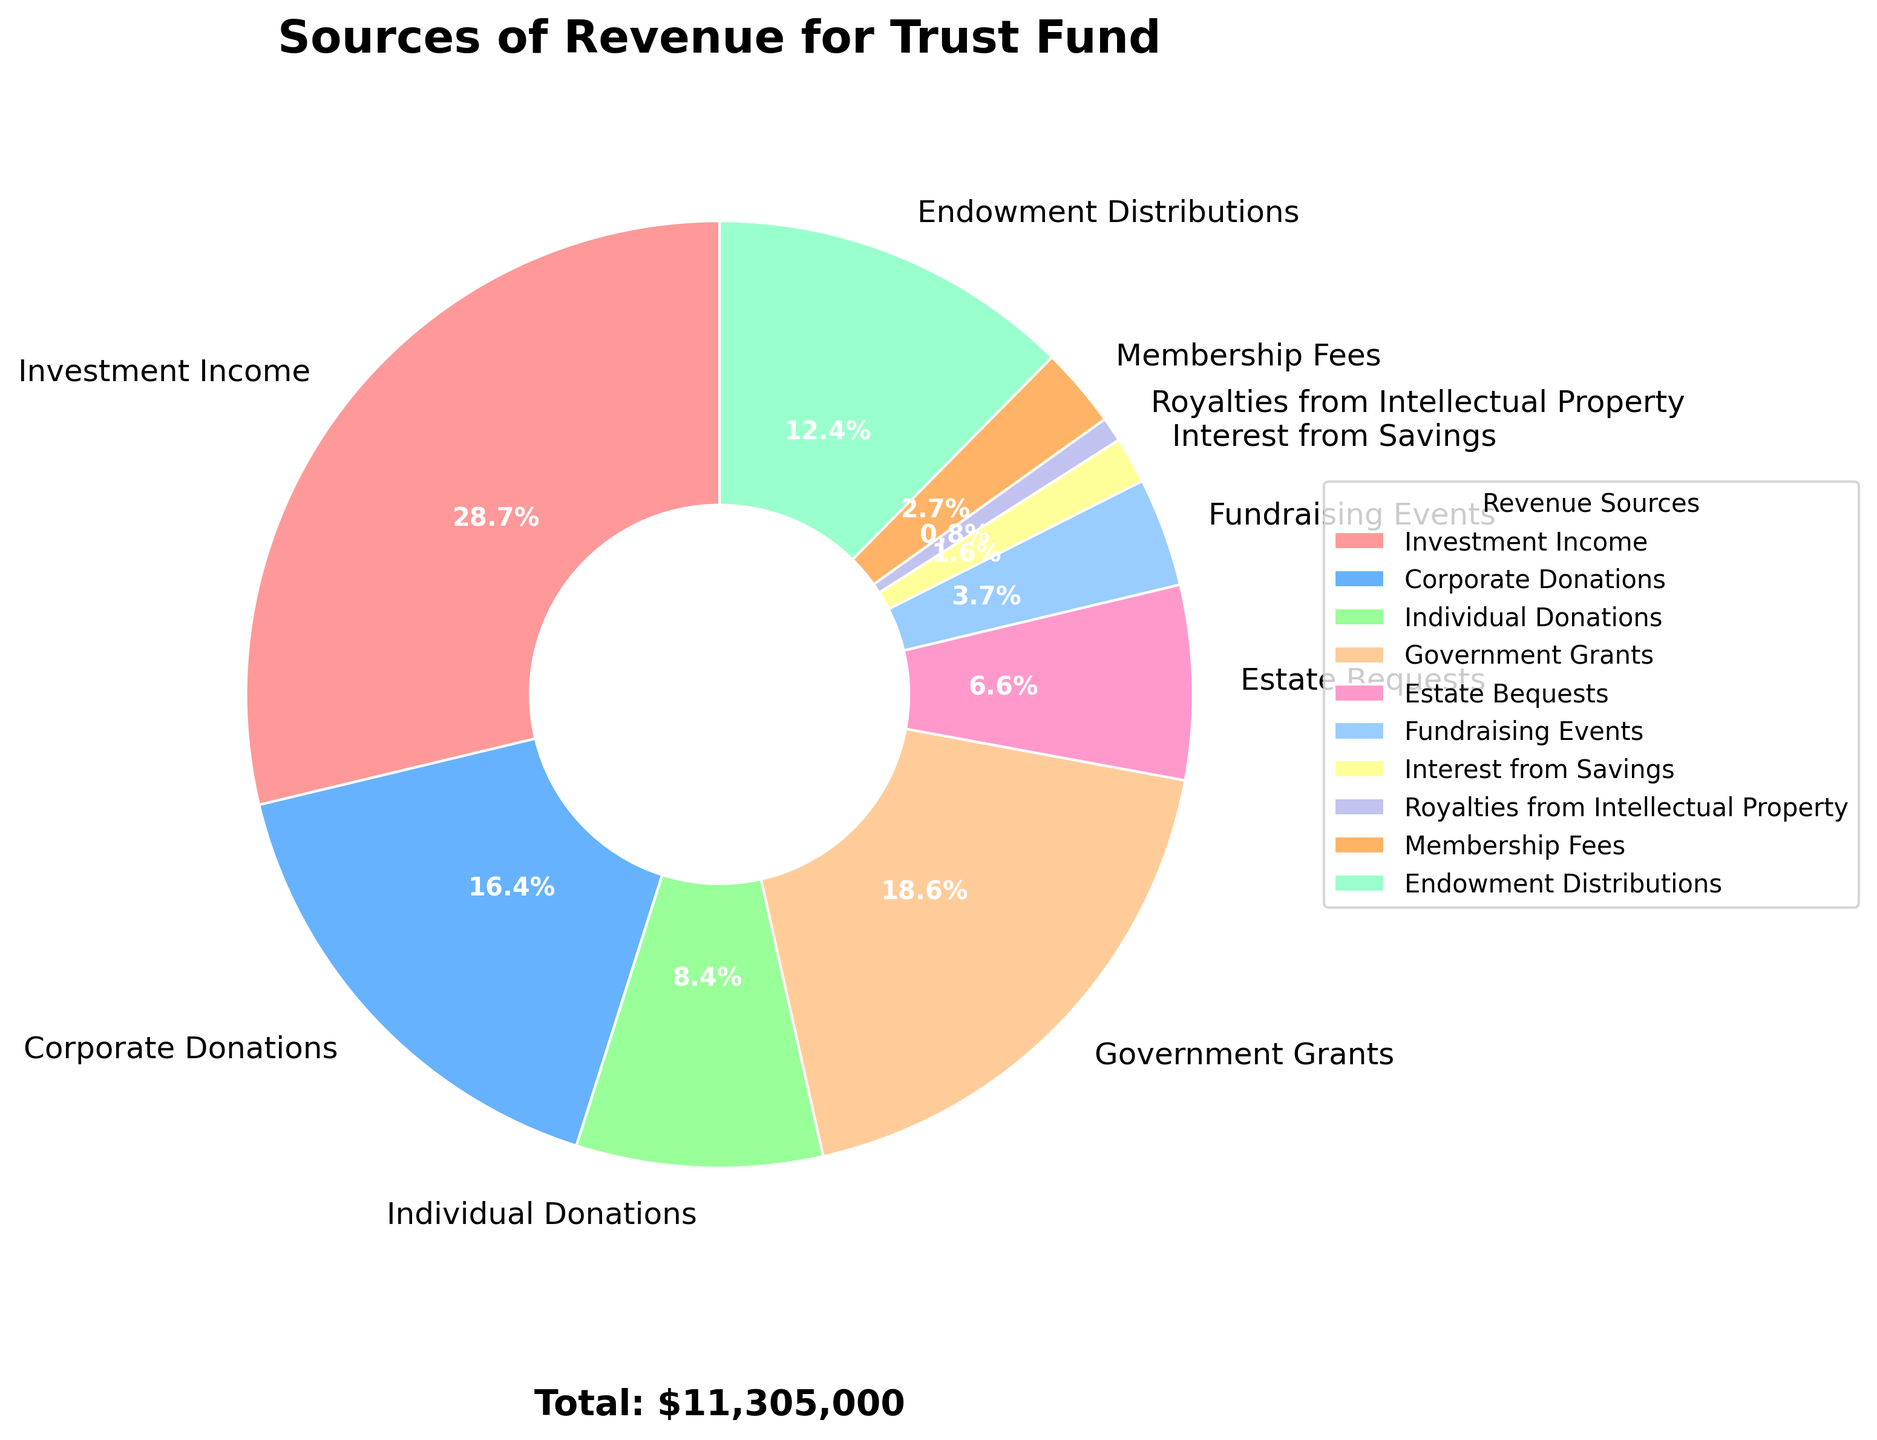What is the largest source of revenue for the trust fund? The largest portion of the pie chart corresponds to Investment Income. By visually comparing the sections, it is clear that Investment Income takes up the most space.
Answer: Investment Income How much more does Endowment Distributions contribute compared to Corporate Donations? Endowment Distributions amount to $1,400,000 while Corporate Donations are $1,850,000. The difference is calculated as $1,850,000 - $1,400,000.
Answer: $450,000 What percentage of the total revenue is contributed by Government Grants and Individual Donations combined? Government Grants contribute $2,100,000 and Individual Donations contribute $950,000. The total revenue is $9,165,000. The combined contribution is $2,100,000 + $950,000 = $3,050,000. The percentage is calculated as ($3,050,000 / $9,165,000) * 100.
Answer: 33.3% Which source of revenue is the smallest, and what is its percentage of the total? By observing the pie chart, Royalties from Intellectual Property is the smallest segment. To find its percentage, divide $95,000 by total revenue $9,165,000 and multiply by 100.
Answer: 1.0% How does the revenue from Fundraising Events compare to Estate Bequests? Fundraising Events contribute $420,000 while Estate Bequests contribute $750,000. Estate Bequests are larger.
Answer: Estate Bequests are larger What is the total revenue contributed by sources contributing less than $500,000 each? The sources contributing less than $500,000 are Interest from Savings ($180,000), Royalties from Intellectual Property ($95,000), Membership Fees ($310,000), and Fundraising Events ($420,000). The total is $180,000 + $95,000 + $310,000 + $420,000.
Answer: $1,005,000 What is the second largest source of revenue? By observing the pie chart and noting the sizes of the sections, the second largest source is Corporate Donations.
Answer: Corporate Donations How much less does Estate Bequests contribute compared to Investment Income? Estate Bequests contribute $750,000 and Investment Income contributes $3,250,000. The difference is $3,250,000 - $750,000.
Answer: $2,500,000 What is the total revenue from sources contributing more than $1,000,000 each? The sources contributing more than $1,000,000 are Investment Income ($3,250,000), Corporate Donations ($1,850,000), Government Grants ($2,100,000), and Endowment Distributions ($1,400,000). The total is $3,250,000 + $1,850,000 + $2,100,000 + $1,400,000.
Answer: $8,600,000 